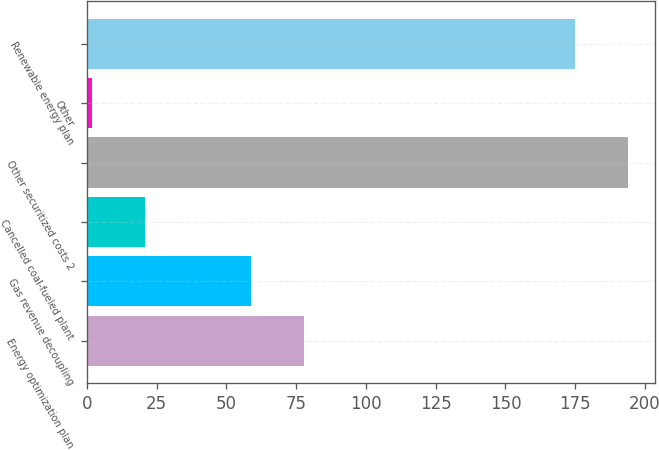Convert chart. <chart><loc_0><loc_0><loc_500><loc_500><bar_chart><fcel>Energy optimization plan<fcel>Gas revenue decoupling<fcel>Cancelled coal-fueled plant<fcel>Other securitized costs 2<fcel>Other<fcel>Renewable energy plan<nl><fcel>78<fcel>59<fcel>21<fcel>194<fcel>2<fcel>175<nl></chart> 